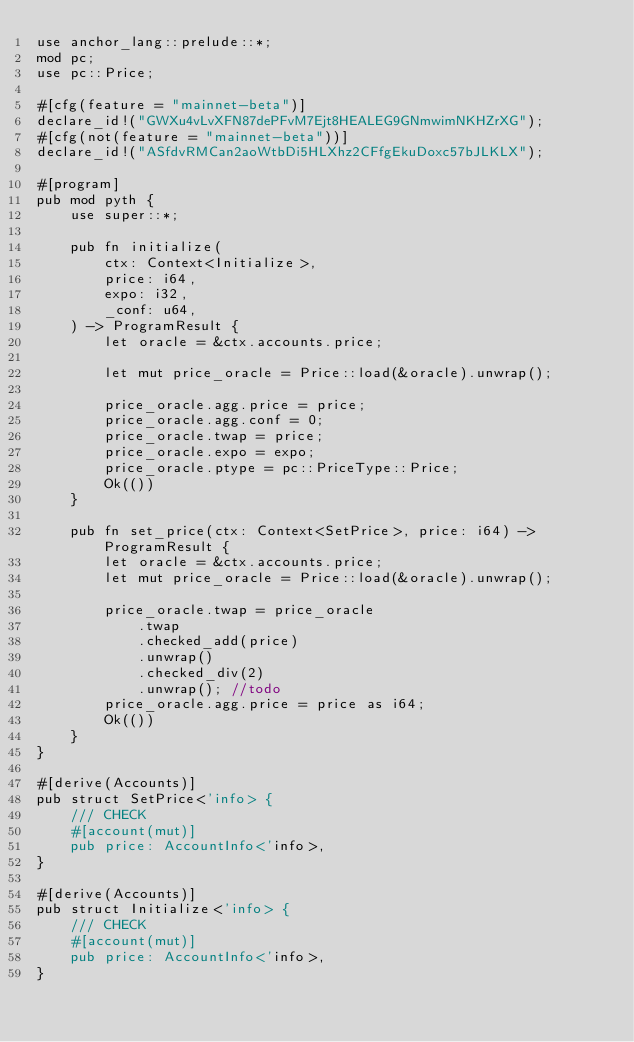Convert code to text. <code><loc_0><loc_0><loc_500><loc_500><_Rust_>use anchor_lang::prelude::*;
mod pc;
use pc::Price;

#[cfg(feature = "mainnet-beta")]
declare_id!("GWXu4vLvXFN87dePFvM7Ejt8HEALEG9GNmwimNKHZrXG");
#[cfg(not(feature = "mainnet-beta"))]
declare_id!("ASfdvRMCan2aoWtbDi5HLXhz2CFfgEkuDoxc57bJLKLX");

#[program]
pub mod pyth {
    use super::*;

    pub fn initialize(
        ctx: Context<Initialize>,
        price: i64,
        expo: i32,
        _conf: u64,
    ) -> ProgramResult {
        let oracle = &ctx.accounts.price;

        let mut price_oracle = Price::load(&oracle).unwrap();

        price_oracle.agg.price = price;
        price_oracle.agg.conf = 0;
        price_oracle.twap = price;
        price_oracle.expo = expo;
        price_oracle.ptype = pc::PriceType::Price;
        Ok(())
    }

    pub fn set_price(ctx: Context<SetPrice>, price: i64) -> ProgramResult {
        let oracle = &ctx.accounts.price;
        let mut price_oracle = Price::load(&oracle).unwrap();

        price_oracle.twap = price_oracle
            .twap
            .checked_add(price)
            .unwrap()
            .checked_div(2)
            .unwrap(); //todo
        price_oracle.agg.price = price as i64;
        Ok(())
    }
}

#[derive(Accounts)]
pub struct SetPrice<'info> {
    /// CHECK
    #[account(mut)]
    pub price: AccountInfo<'info>,
}

#[derive(Accounts)]
pub struct Initialize<'info> {
    /// CHECK
    #[account(mut)]
    pub price: AccountInfo<'info>,
}
</code> 